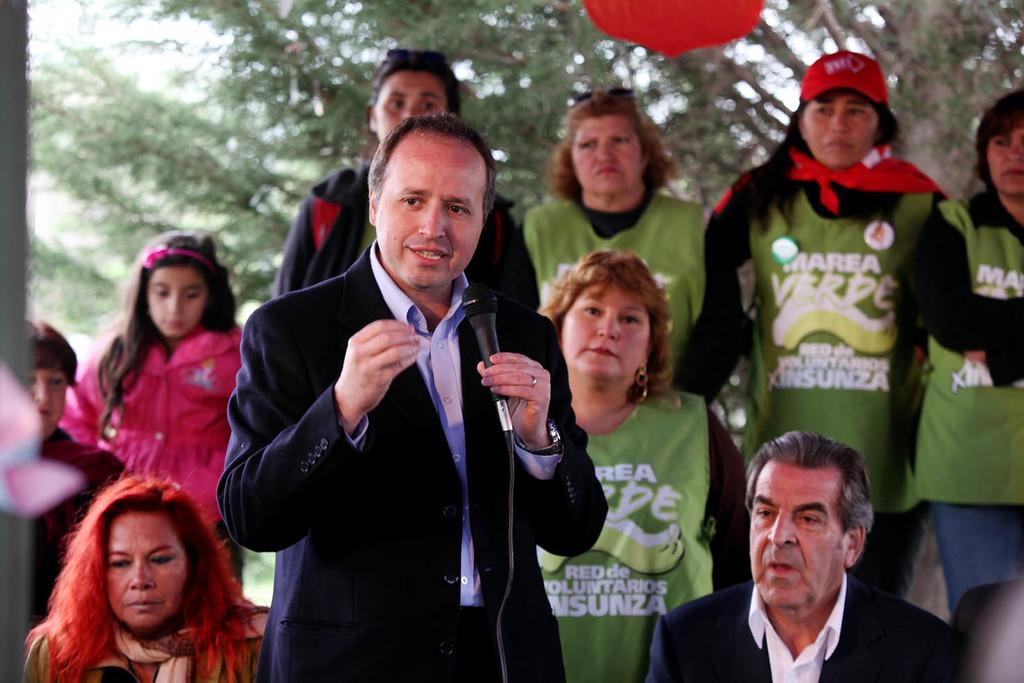What is the man in the image doing? The man is standing in the image and holding a microphone in his hand. Are there any other people in the image besides the man? Yes, there is a group of people standing at the back. What can be seen in the background of the image? Trees and the sky are visible in the image. What type of hot beverage is the writer drinking in the image? There is no writer or hot beverage present in the image. Can you tell me how many hens are visible in the image? There are no hens present in the image. 